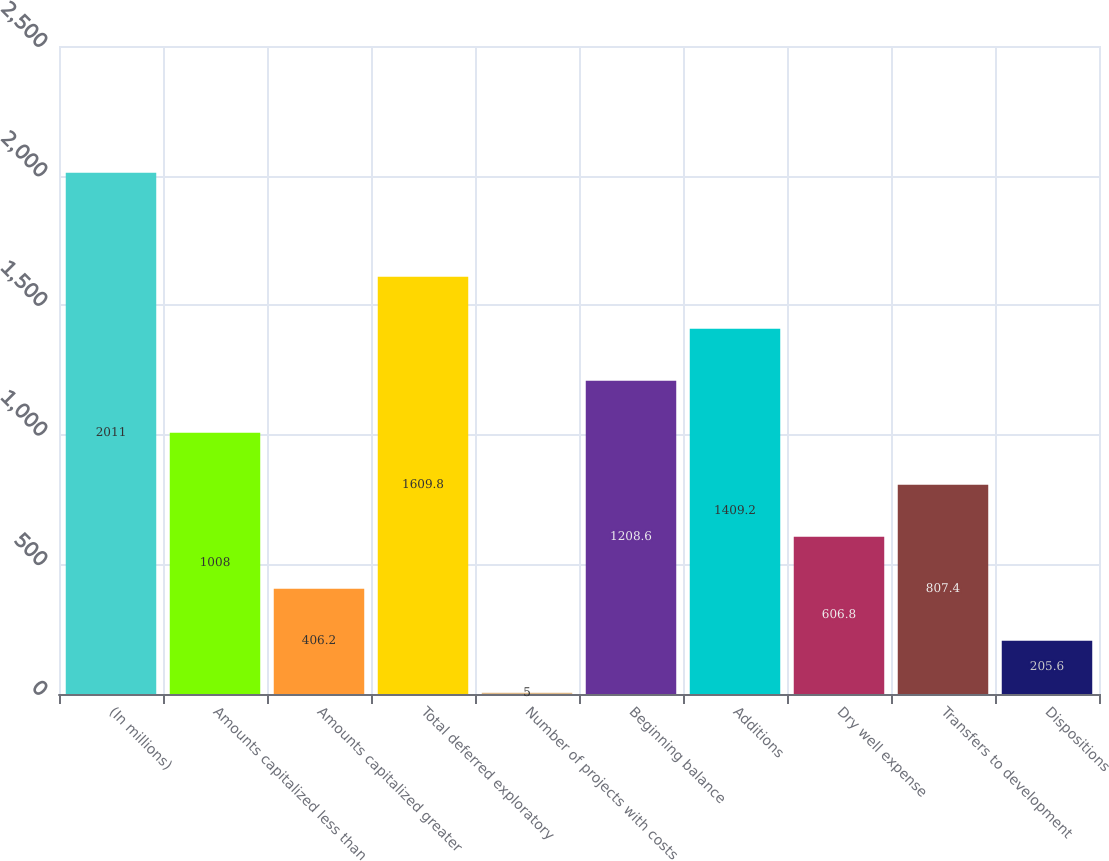Convert chart to OTSL. <chart><loc_0><loc_0><loc_500><loc_500><bar_chart><fcel>(In millions)<fcel>Amounts capitalized less than<fcel>Amounts capitalized greater<fcel>Total deferred exploratory<fcel>Number of projects with costs<fcel>Beginning balance<fcel>Additions<fcel>Dry well expense<fcel>Transfers to development<fcel>Dispositions<nl><fcel>2011<fcel>1008<fcel>406.2<fcel>1609.8<fcel>5<fcel>1208.6<fcel>1409.2<fcel>606.8<fcel>807.4<fcel>205.6<nl></chart> 